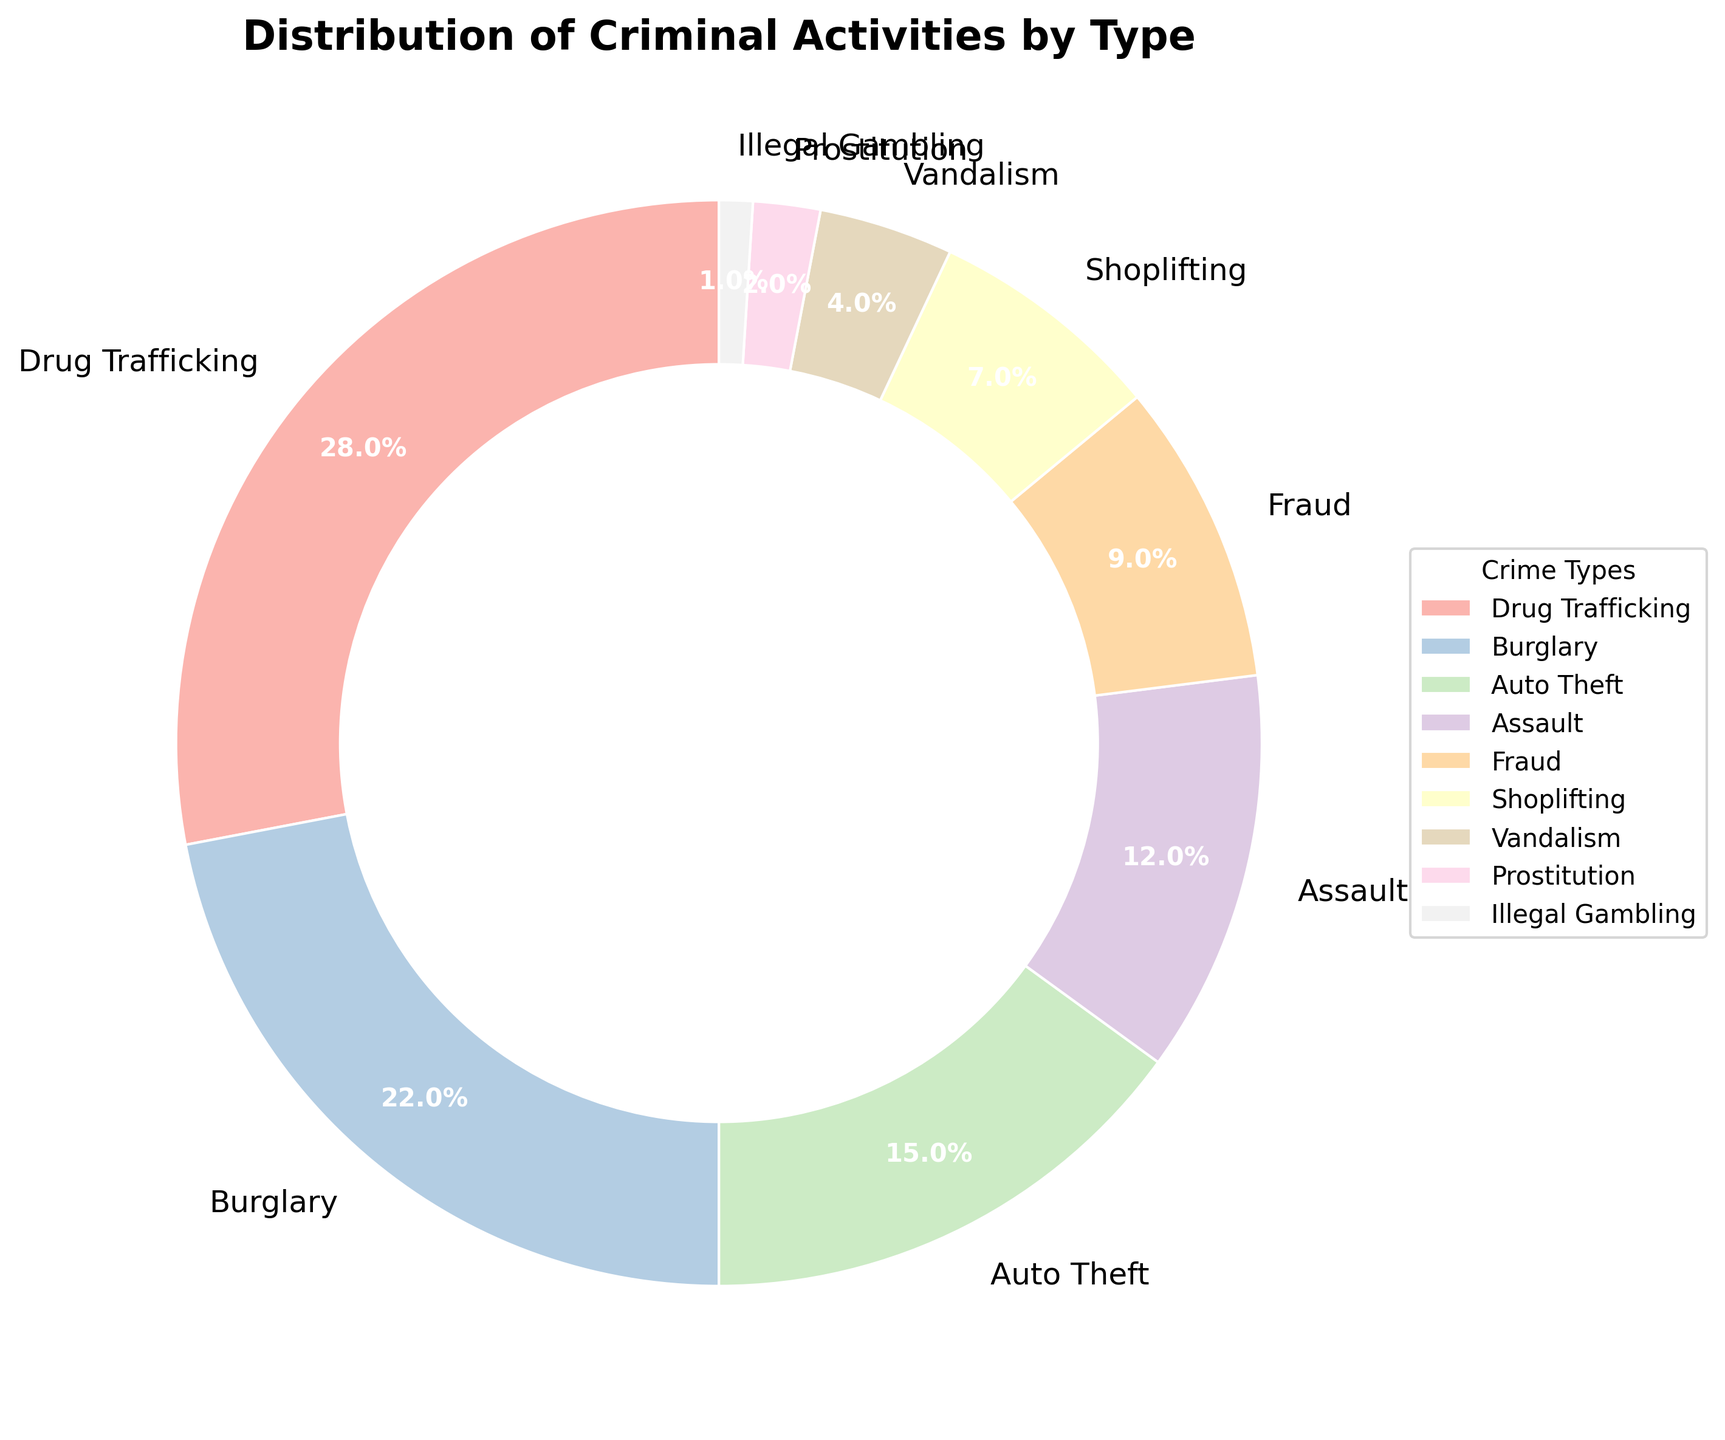Which crime type has the largest percentage? The pie chart indicates the size of each wedge corresponding to different crime types. The largest wedge visually represents Drug Trafficking at 28%.
Answer: Drug Trafficking Which crime types have a percentage greater than 20%? The chart visually shows that the wedges for Drug Trafficking and Burglary are larger than 20%. Drug Trafficking is at 28%, and Burglary is at 22%.
Answer: Drug Trafficking, Burglary How many crime types are represented in the chart? By looking at the legend and counting the distinct categories listed, we can see that there are 9 different crime types represented in the chart.
Answer: 9 What is the combined percentage of Auto Theft and Assault? Auto Theft and Assault segments are 15% and 12%, respectively. Adding these percentages: 15% + 12% = 27%.
Answer: 27% Which crime type has the smallest percentage? The smallest wedge in the pie chart represents Illegal Gambling at 1%.
Answer: Illegal Gambling Compare the percentages of Fraud and Shoplifting. Which is higher and by how much? The wedge for Fraud shows 9% and Shoplifting shows 7%. Subtract the smaller percentage from the larger: 9% - 7% = 2%. Fraud is higher by 2%.
Answer: Fraud is higher by 2% Are there more violent crimes (Assault) or property crimes (Burglary, Auto Theft, Vandalism)? What is the difference in their total percentages? The total percentage for property crimes is the sum of Burglary, Auto Theft, and Vandalism: 22% + 15% + 4% = 41%. Assault alone is 12%. The difference is 41% - 12% = 29%.
Answer: Property crimes are higher by 29% What's the average percentage of Drug Trafficking, Burglary, and Fraud? Adding the percentages for these three types: 28% + 22% + 9% = 59%. Dividing by the number of types (3): 59% / 3 = 19.67%.
Answer: 19.67% What proportion of the total percentage is covered by non-violent crimes (all except Assault)? Adding the percentages for all non-violent crimes: 28% + 22% + 15% + 9% + 7% + 4% + 2% + 1% = 88%.
Answer: 88% 